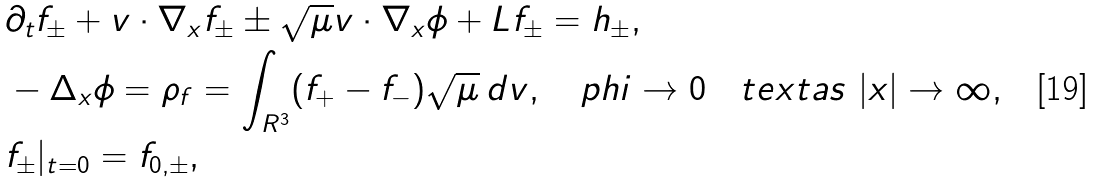Convert formula to latex. <formula><loc_0><loc_0><loc_500><loc_500>& \partial _ { t } f _ { \pm } + v \cdot \nabla _ { x } f _ { \pm } \pm \sqrt { \mu } v \cdot \nabla _ { x } \phi + L f _ { \pm } = h _ { \pm } , \\ & - \Delta _ { x } \phi = \rho _ { f } = \int _ { { R } ^ { 3 } } ( f _ { + } - f _ { - } ) \sqrt { \mu } \, d v , \quad p h i \rightarrow 0 \quad t e x t { a s } \ | x | \rightarrow \infty , \\ & f _ { \pm } | _ { t = 0 } = f _ { 0 , \pm } ,</formula> 